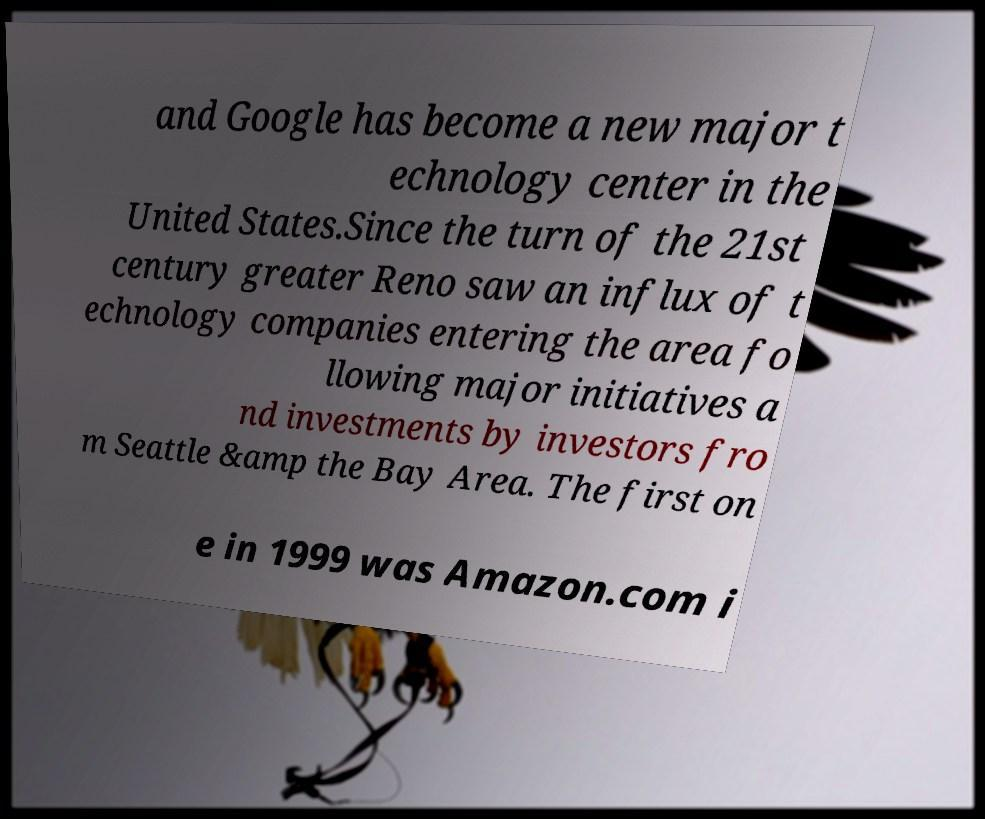Could you assist in decoding the text presented in this image and type it out clearly? and Google has become a new major t echnology center in the United States.Since the turn of the 21st century greater Reno saw an influx of t echnology companies entering the area fo llowing major initiatives a nd investments by investors fro m Seattle &amp the Bay Area. The first on e in 1999 was Amazon.com i 